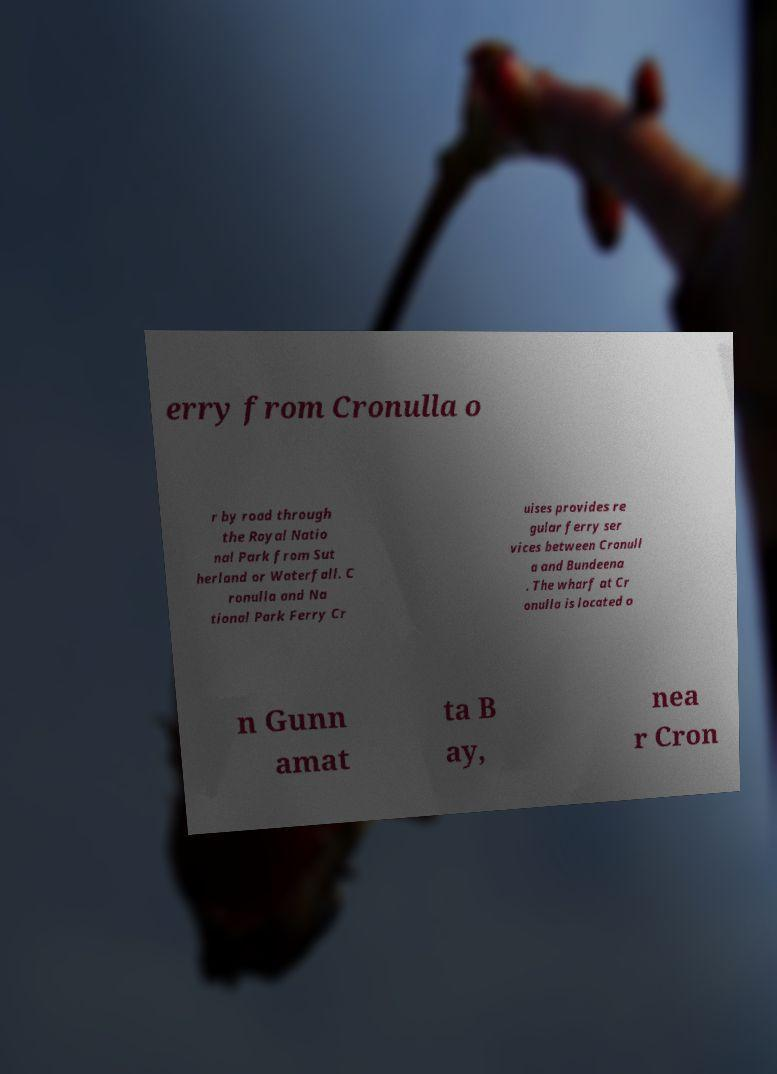I need the written content from this picture converted into text. Can you do that? erry from Cronulla o r by road through the Royal Natio nal Park from Sut herland or Waterfall. C ronulla and Na tional Park Ferry Cr uises provides re gular ferry ser vices between Cronull a and Bundeena . The wharf at Cr onulla is located o n Gunn amat ta B ay, nea r Cron 